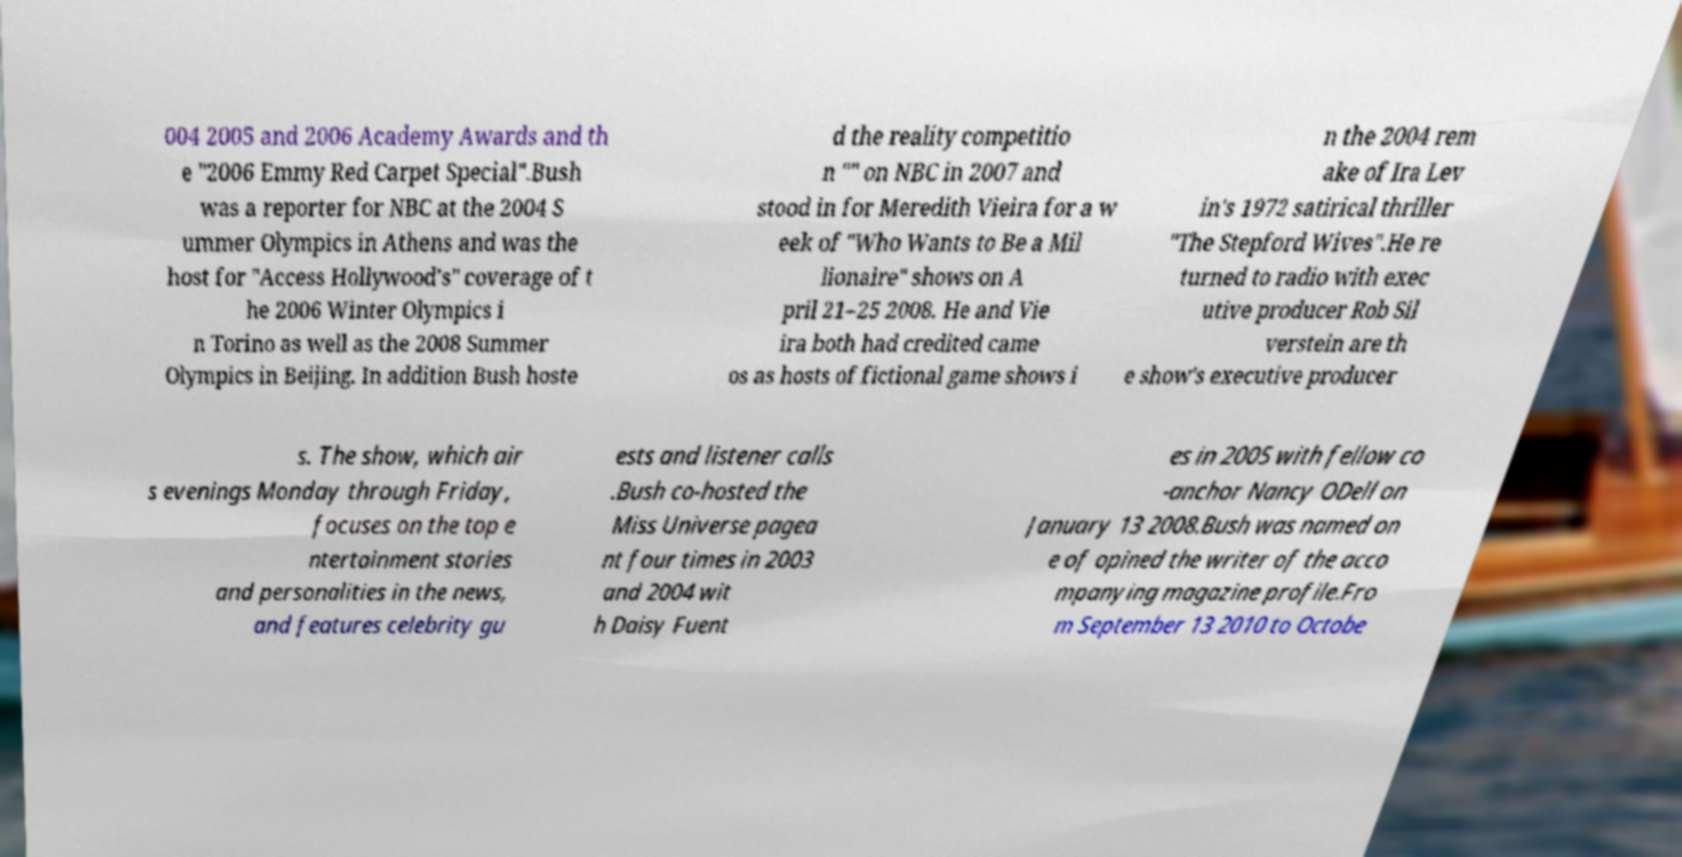Please identify and transcribe the text found in this image. 004 2005 and 2006 Academy Awards and th e "2006 Emmy Red Carpet Special".Bush was a reporter for NBC at the 2004 S ummer Olympics in Athens and was the host for "Access Hollywood's" coverage of t he 2006 Winter Olympics i n Torino as well as the 2008 Summer Olympics in Beijing. In addition Bush hoste d the reality competitio n "" on NBC in 2007 and stood in for Meredith Vieira for a w eek of "Who Wants to Be a Mil lionaire" shows on A pril 21–25 2008. He and Vie ira both had credited came os as hosts of fictional game shows i n the 2004 rem ake of Ira Lev in's 1972 satirical thriller "The Stepford Wives".He re turned to radio with exec utive producer Rob Sil verstein are th e show's executive producer s. The show, which air s evenings Monday through Friday, focuses on the top e ntertainment stories and personalities in the news, and features celebrity gu ests and listener calls .Bush co-hosted the Miss Universe pagea nt four times in 2003 and 2004 wit h Daisy Fuent es in 2005 with fellow co -anchor Nancy ODell on January 13 2008.Bush was named on e of opined the writer of the acco mpanying magazine profile.Fro m September 13 2010 to Octobe 